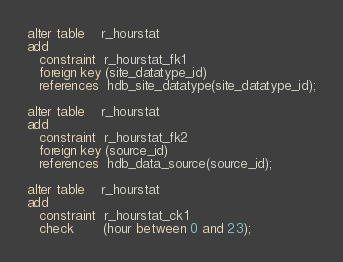<code> <loc_0><loc_0><loc_500><loc_500><_SQL_>alter table    r_hourstat
add
   constraint  r_hourstat_fk1
   foreign key (site_datatype_id)
   references  hdb_site_datatype(site_datatype_id);

alter table    r_hourstat
add
   constraint  r_hourstat_fk2
   foreign key (source_id)
   references  hdb_data_source(source_id);

alter table    r_hourstat
add
   constraint  r_hourstat_ck1
   check       (hour between 0 and 23);
</code> 